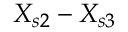Convert formula to latex. <formula><loc_0><loc_0><loc_500><loc_500>X _ { s 2 } - X _ { s 3 }</formula> 